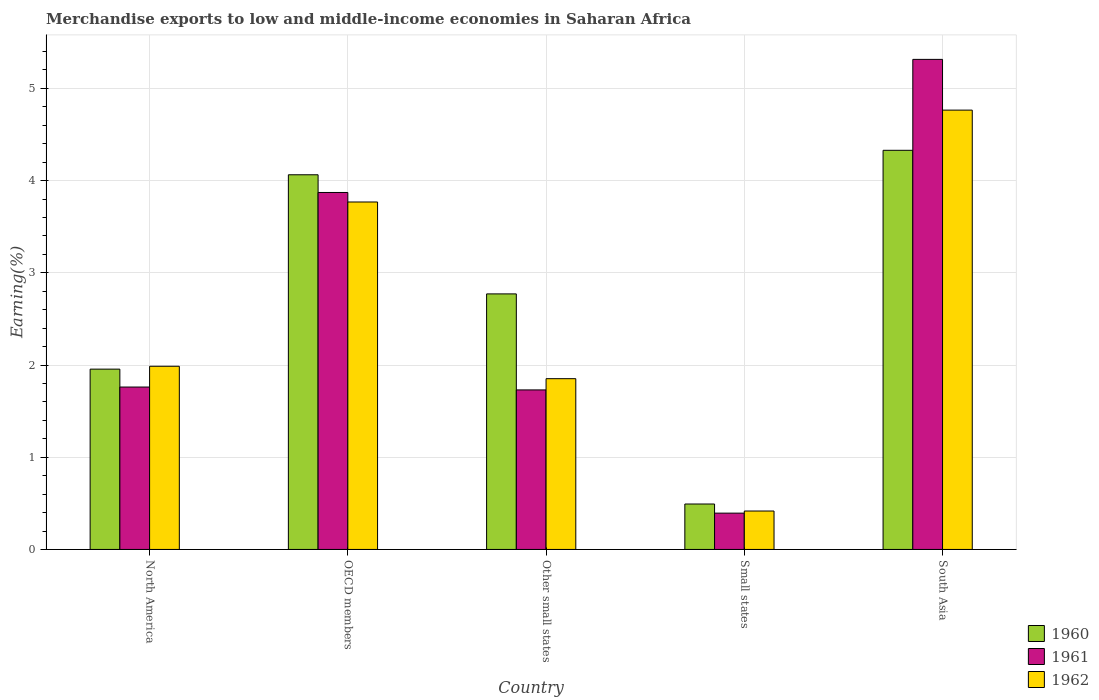How many groups of bars are there?
Ensure brevity in your answer.  5. Are the number of bars on each tick of the X-axis equal?
Your response must be concise. Yes. How many bars are there on the 5th tick from the left?
Offer a terse response. 3. What is the label of the 1st group of bars from the left?
Offer a terse response. North America. What is the percentage of amount earned from merchandise exports in 1961 in Other small states?
Offer a terse response. 1.73. Across all countries, what is the maximum percentage of amount earned from merchandise exports in 1962?
Provide a succinct answer. 4.76. Across all countries, what is the minimum percentage of amount earned from merchandise exports in 1961?
Your answer should be very brief. 0.39. In which country was the percentage of amount earned from merchandise exports in 1962 minimum?
Keep it short and to the point. Small states. What is the total percentage of amount earned from merchandise exports in 1960 in the graph?
Your answer should be very brief. 13.61. What is the difference between the percentage of amount earned from merchandise exports in 1960 in North America and that in Small states?
Your response must be concise. 1.46. What is the difference between the percentage of amount earned from merchandise exports in 1961 in OECD members and the percentage of amount earned from merchandise exports in 1960 in South Asia?
Give a very brief answer. -0.46. What is the average percentage of amount earned from merchandise exports in 1962 per country?
Offer a very short reply. 2.56. What is the difference between the percentage of amount earned from merchandise exports of/in 1962 and percentage of amount earned from merchandise exports of/in 1961 in OECD members?
Keep it short and to the point. -0.1. In how many countries, is the percentage of amount earned from merchandise exports in 1962 greater than 2.6 %?
Make the answer very short. 2. What is the ratio of the percentage of amount earned from merchandise exports in 1961 in OECD members to that in South Asia?
Offer a very short reply. 0.73. What is the difference between the highest and the second highest percentage of amount earned from merchandise exports in 1961?
Your answer should be compact. -2.11. What is the difference between the highest and the lowest percentage of amount earned from merchandise exports in 1960?
Offer a terse response. 3.84. In how many countries, is the percentage of amount earned from merchandise exports in 1960 greater than the average percentage of amount earned from merchandise exports in 1960 taken over all countries?
Give a very brief answer. 3. How many bars are there?
Give a very brief answer. 15. Are all the bars in the graph horizontal?
Give a very brief answer. No. How many countries are there in the graph?
Offer a very short reply. 5. Does the graph contain grids?
Keep it short and to the point. Yes. How many legend labels are there?
Offer a terse response. 3. What is the title of the graph?
Provide a short and direct response. Merchandise exports to low and middle-income economies in Saharan Africa. Does "1976" appear as one of the legend labels in the graph?
Keep it short and to the point. No. What is the label or title of the Y-axis?
Your response must be concise. Earning(%). What is the Earning(%) of 1960 in North America?
Your answer should be compact. 1.96. What is the Earning(%) of 1961 in North America?
Ensure brevity in your answer.  1.76. What is the Earning(%) of 1962 in North America?
Keep it short and to the point. 1.99. What is the Earning(%) in 1960 in OECD members?
Provide a succinct answer. 4.06. What is the Earning(%) of 1961 in OECD members?
Ensure brevity in your answer.  3.87. What is the Earning(%) of 1962 in OECD members?
Offer a terse response. 3.77. What is the Earning(%) in 1960 in Other small states?
Make the answer very short. 2.77. What is the Earning(%) in 1961 in Other small states?
Provide a short and direct response. 1.73. What is the Earning(%) in 1962 in Other small states?
Provide a short and direct response. 1.85. What is the Earning(%) of 1960 in Small states?
Give a very brief answer. 0.49. What is the Earning(%) of 1961 in Small states?
Offer a terse response. 0.39. What is the Earning(%) of 1962 in Small states?
Offer a very short reply. 0.42. What is the Earning(%) in 1960 in South Asia?
Provide a short and direct response. 4.33. What is the Earning(%) of 1961 in South Asia?
Your answer should be compact. 5.31. What is the Earning(%) of 1962 in South Asia?
Provide a succinct answer. 4.76. Across all countries, what is the maximum Earning(%) of 1960?
Ensure brevity in your answer.  4.33. Across all countries, what is the maximum Earning(%) in 1961?
Make the answer very short. 5.31. Across all countries, what is the maximum Earning(%) of 1962?
Offer a terse response. 4.76. Across all countries, what is the minimum Earning(%) of 1960?
Your response must be concise. 0.49. Across all countries, what is the minimum Earning(%) in 1961?
Make the answer very short. 0.39. Across all countries, what is the minimum Earning(%) of 1962?
Provide a short and direct response. 0.42. What is the total Earning(%) in 1960 in the graph?
Keep it short and to the point. 13.61. What is the total Earning(%) in 1961 in the graph?
Your response must be concise. 13.07. What is the total Earning(%) in 1962 in the graph?
Your answer should be very brief. 12.79. What is the difference between the Earning(%) in 1960 in North America and that in OECD members?
Your response must be concise. -2.11. What is the difference between the Earning(%) of 1961 in North America and that in OECD members?
Make the answer very short. -2.11. What is the difference between the Earning(%) in 1962 in North America and that in OECD members?
Ensure brevity in your answer.  -1.78. What is the difference between the Earning(%) of 1960 in North America and that in Other small states?
Provide a short and direct response. -0.82. What is the difference between the Earning(%) of 1961 in North America and that in Other small states?
Keep it short and to the point. 0.03. What is the difference between the Earning(%) of 1962 in North America and that in Other small states?
Provide a succinct answer. 0.13. What is the difference between the Earning(%) of 1960 in North America and that in Small states?
Your response must be concise. 1.46. What is the difference between the Earning(%) of 1961 in North America and that in Small states?
Provide a succinct answer. 1.37. What is the difference between the Earning(%) in 1962 in North America and that in Small states?
Your response must be concise. 1.57. What is the difference between the Earning(%) of 1960 in North America and that in South Asia?
Ensure brevity in your answer.  -2.37. What is the difference between the Earning(%) in 1961 in North America and that in South Asia?
Offer a very short reply. -3.55. What is the difference between the Earning(%) in 1962 in North America and that in South Asia?
Provide a succinct answer. -2.78. What is the difference between the Earning(%) in 1960 in OECD members and that in Other small states?
Provide a short and direct response. 1.29. What is the difference between the Earning(%) in 1961 in OECD members and that in Other small states?
Your response must be concise. 2.14. What is the difference between the Earning(%) of 1962 in OECD members and that in Other small states?
Give a very brief answer. 1.92. What is the difference between the Earning(%) in 1960 in OECD members and that in Small states?
Provide a succinct answer. 3.57. What is the difference between the Earning(%) in 1961 in OECD members and that in Small states?
Your response must be concise. 3.48. What is the difference between the Earning(%) in 1962 in OECD members and that in Small states?
Your response must be concise. 3.35. What is the difference between the Earning(%) in 1960 in OECD members and that in South Asia?
Make the answer very short. -0.27. What is the difference between the Earning(%) of 1961 in OECD members and that in South Asia?
Offer a terse response. -1.44. What is the difference between the Earning(%) in 1962 in OECD members and that in South Asia?
Make the answer very short. -1. What is the difference between the Earning(%) of 1960 in Other small states and that in Small states?
Make the answer very short. 2.28. What is the difference between the Earning(%) in 1961 in Other small states and that in Small states?
Your answer should be very brief. 1.34. What is the difference between the Earning(%) of 1962 in Other small states and that in Small states?
Provide a succinct answer. 1.44. What is the difference between the Earning(%) of 1960 in Other small states and that in South Asia?
Your answer should be very brief. -1.56. What is the difference between the Earning(%) in 1961 in Other small states and that in South Asia?
Your response must be concise. -3.58. What is the difference between the Earning(%) in 1962 in Other small states and that in South Asia?
Offer a terse response. -2.91. What is the difference between the Earning(%) of 1960 in Small states and that in South Asia?
Provide a short and direct response. -3.84. What is the difference between the Earning(%) of 1961 in Small states and that in South Asia?
Provide a succinct answer. -4.92. What is the difference between the Earning(%) in 1962 in Small states and that in South Asia?
Offer a terse response. -4.35. What is the difference between the Earning(%) of 1960 in North America and the Earning(%) of 1961 in OECD members?
Provide a succinct answer. -1.92. What is the difference between the Earning(%) in 1960 in North America and the Earning(%) in 1962 in OECD members?
Keep it short and to the point. -1.81. What is the difference between the Earning(%) in 1961 in North America and the Earning(%) in 1962 in OECD members?
Your answer should be very brief. -2.01. What is the difference between the Earning(%) in 1960 in North America and the Earning(%) in 1961 in Other small states?
Provide a succinct answer. 0.23. What is the difference between the Earning(%) of 1960 in North America and the Earning(%) of 1962 in Other small states?
Your answer should be very brief. 0.1. What is the difference between the Earning(%) in 1961 in North America and the Earning(%) in 1962 in Other small states?
Give a very brief answer. -0.09. What is the difference between the Earning(%) in 1960 in North America and the Earning(%) in 1961 in Small states?
Your answer should be compact. 1.56. What is the difference between the Earning(%) of 1960 in North America and the Earning(%) of 1962 in Small states?
Keep it short and to the point. 1.54. What is the difference between the Earning(%) in 1961 in North America and the Earning(%) in 1962 in Small states?
Ensure brevity in your answer.  1.34. What is the difference between the Earning(%) of 1960 in North America and the Earning(%) of 1961 in South Asia?
Make the answer very short. -3.36. What is the difference between the Earning(%) in 1960 in North America and the Earning(%) in 1962 in South Asia?
Make the answer very short. -2.81. What is the difference between the Earning(%) in 1961 in North America and the Earning(%) in 1962 in South Asia?
Provide a short and direct response. -3. What is the difference between the Earning(%) in 1960 in OECD members and the Earning(%) in 1961 in Other small states?
Provide a short and direct response. 2.33. What is the difference between the Earning(%) in 1960 in OECD members and the Earning(%) in 1962 in Other small states?
Give a very brief answer. 2.21. What is the difference between the Earning(%) in 1961 in OECD members and the Earning(%) in 1962 in Other small states?
Make the answer very short. 2.02. What is the difference between the Earning(%) of 1960 in OECD members and the Earning(%) of 1961 in Small states?
Provide a short and direct response. 3.67. What is the difference between the Earning(%) in 1960 in OECD members and the Earning(%) in 1962 in Small states?
Your response must be concise. 3.65. What is the difference between the Earning(%) in 1961 in OECD members and the Earning(%) in 1962 in Small states?
Make the answer very short. 3.45. What is the difference between the Earning(%) in 1960 in OECD members and the Earning(%) in 1961 in South Asia?
Keep it short and to the point. -1.25. What is the difference between the Earning(%) in 1960 in OECD members and the Earning(%) in 1962 in South Asia?
Ensure brevity in your answer.  -0.7. What is the difference between the Earning(%) in 1961 in OECD members and the Earning(%) in 1962 in South Asia?
Your response must be concise. -0.89. What is the difference between the Earning(%) in 1960 in Other small states and the Earning(%) in 1961 in Small states?
Give a very brief answer. 2.38. What is the difference between the Earning(%) in 1960 in Other small states and the Earning(%) in 1962 in Small states?
Your response must be concise. 2.35. What is the difference between the Earning(%) of 1961 in Other small states and the Earning(%) of 1962 in Small states?
Give a very brief answer. 1.31. What is the difference between the Earning(%) in 1960 in Other small states and the Earning(%) in 1961 in South Asia?
Make the answer very short. -2.54. What is the difference between the Earning(%) of 1960 in Other small states and the Earning(%) of 1962 in South Asia?
Offer a very short reply. -1.99. What is the difference between the Earning(%) in 1961 in Other small states and the Earning(%) in 1962 in South Asia?
Give a very brief answer. -3.03. What is the difference between the Earning(%) in 1960 in Small states and the Earning(%) in 1961 in South Asia?
Your answer should be compact. -4.82. What is the difference between the Earning(%) of 1960 in Small states and the Earning(%) of 1962 in South Asia?
Provide a succinct answer. -4.27. What is the difference between the Earning(%) of 1961 in Small states and the Earning(%) of 1962 in South Asia?
Ensure brevity in your answer.  -4.37. What is the average Earning(%) in 1960 per country?
Offer a terse response. 2.72. What is the average Earning(%) in 1961 per country?
Offer a very short reply. 2.61. What is the average Earning(%) in 1962 per country?
Your response must be concise. 2.56. What is the difference between the Earning(%) of 1960 and Earning(%) of 1961 in North America?
Your response must be concise. 0.19. What is the difference between the Earning(%) of 1960 and Earning(%) of 1962 in North America?
Ensure brevity in your answer.  -0.03. What is the difference between the Earning(%) of 1961 and Earning(%) of 1962 in North America?
Offer a terse response. -0.23. What is the difference between the Earning(%) in 1960 and Earning(%) in 1961 in OECD members?
Make the answer very short. 0.19. What is the difference between the Earning(%) in 1960 and Earning(%) in 1962 in OECD members?
Your answer should be compact. 0.3. What is the difference between the Earning(%) of 1961 and Earning(%) of 1962 in OECD members?
Provide a short and direct response. 0.1. What is the difference between the Earning(%) in 1960 and Earning(%) in 1961 in Other small states?
Provide a short and direct response. 1.04. What is the difference between the Earning(%) in 1960 and Earning(%) in 1962 in Other small states?
Give a very brief answer. 0.92. What is the difference between the Earning(%) in 1961 and Earning(%) in 1962 in Other small states?
Your response must be concise. -0.12. What is the difference between the Earning(%) in 1960 and Earning(%) in 1961 in Small states?
Provide a succinct answer. 0.1. What is the difference between the Earning(%) of 1960 and Earning(%) of 1962 in Small states?
Give a very brief answer. 0.08. What is the difference between the Earning(%) of 1961 and Earning(%) of 1962 in Small states?
Your response must be concise. -0.02. What is the difference between the Earning(%) in 1960 and Earning(%) in 1961 in South Asia?
Provide a short and direct response. -0.99. What is the difference between the Earning(%) in 1960 and Earning(%) in 1962 in South Asia?
Make the answer very short. -0.44. What is the difference between the Earning(%) of 1961 and Earning(%) of 1962 in South Asia?
Your answer should be compact. 0.55. What is the ratio of the Earning(%) in 1960 in North America to that in OECD members?
Ensure brevity in your answer.  0.48. What is the ratio of the Earning(%) in 1961 in North America to that in OECD members?
Provide a succinct answer. 0.46. What is the ratio of the Earning(%) in 1962 in North America to that in OECD members?
Your response must be concise. 0.53. What is the ratio of the Earning(%) of 1960 in North America to that in Other small states?
Your response must be concise. 0.71. What is the ratio of the Earning(%) of 1962 in North America to that in Other small states?
Your answer should be very brief. 1.07. What is the ratio of the Earning(%) in 1960 in North America to that in Small states?
Offer a very short reply. 3.97. What is the ratio of the Earning(%) in 1961 in North America to that in Small states?
Keep it short and to the point. 4.47. What is the ratio of the Earning(%) of 1962 in North America to that in Small states?
Offer a very short reply. 4.77. What is the ratio of the Earning(%) of 1960 in North America to that in South Asia?
Your answer should be compact. 0.45. What is the ratio of the Earning(%) of 1961 in North America to that in South Asia?
Keep it short and to the point. 0.33. What is the ratio of the Earning(%) in 1962 in North America to that in South Asia?
Provide a short and direct response. 0.42. What is the ratio of the Earning(%) of 1960 in OECD members to that in Other small states?
Your answer should be compact. 1.47. What is the ratio of the Earning(%) in 1961 in OECD members to that in Other small states?
Offer a very short reply. 2.24. What is the ratio of the Earning(%) of 1962 in OECD members to that in Other small states?
Provide a succinct answer. 2.03. What is the ratio of the Earning(%) of 1960 in OECD members to that in Small states?
Provide a succinct answer. 8.25. What is the ratio of the Earning(%) of 1961 in OECD members to that in Small states?
Make the answer very short. 9.83. What is the ratio of the Earning(%) of 1962 in OECD members to that in Small states?
Ensure brevity in your answer.  9.04. What is the ratio of the Earning(%) in 1960 in OECD members to that in South Asia?
Your answer should be very brief. 0.94. What is the ratio of the Earning(%) in 1961 in OECD members to that in South Asia?
Your answer should be compact. 0.73. What is the ratio of the Earning(%) of 1962 in OECD members to that in South Asia?
Give a very brief answer. 0.79. What is the ratio of the Earning(%) in 1960 in Other small states to that in Small states?
Keep it short and to the point. 5.62. What is the ratio of the Earning(%) in 1961 in Other small states to that in Small states?
Ensure brevity in your answer.  4.39. What is the ratio of the Earning(%) of 1962 in Other small states to that in Small states?
Give a very brief answer. 4.44. What is the ratio of the Earning(%) of 1960 in Other small states to that in South Asia?
Provide a succinct answer. 0.64. What is the ratio of the Earning(%) of 1961 in Other small states to that in South Asia?
Your response must be concise. 0.33. What is the ratio of the Earning(%) of 1962 in Other small states to that in South Asia?
Provide a succinct answer. 0.39. What is the ratio of the Earning(%) of 1960 in Small states to that in South Asia?
Offer a terse response. 0.11. What is the ratio of the Earning(%) in 1961 in Small states to that in South Asia?
Your response must be concise. 0.07. What is the ratio of the Earning(%) in 1962 in Small states to that in South Asia?
Your response must be concise. 0.09. What is the difference between the highest and the second highest Earning(%) in 1960?
Provide a succinct answer. 0.27. What is the difference between the highest and the second highest Earning(%) of 1961?
Make the answer very short. 1.44. What is the difference between the highest and the second highest Earning(%) in 1962?
Provide a short and direct response. 1. What is the difference between the highest and the lowest Earning(%) of 1960?
Ensure brevity in your answer.  3.84. What is the difference between the highest and the lowest Earning(%) of 1961?
Your response must be concise. 4.92. What is the difference between the highest and the lowest Earning(%) of 1962?
Offer a terse response. 4.35. 